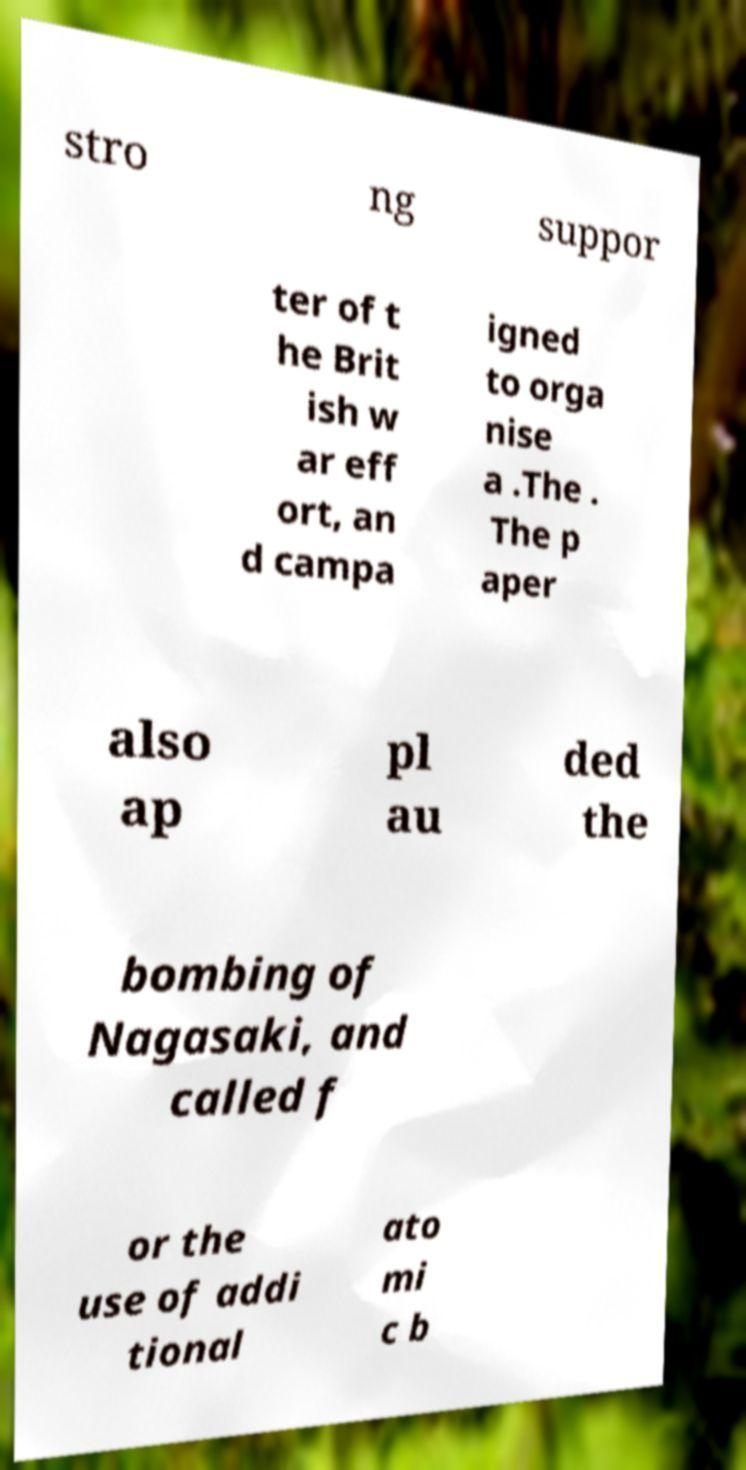For documentation purposes, I need the text within this image transcribed. Could you provide that? stro ng suppor ter of t he Brit ish w ar eff ort, an d campa igned to orga nise a .The . The p aper also ap pl au ded the bombing of Nagasaki, and called f or the use of addi tional ato mi c b 